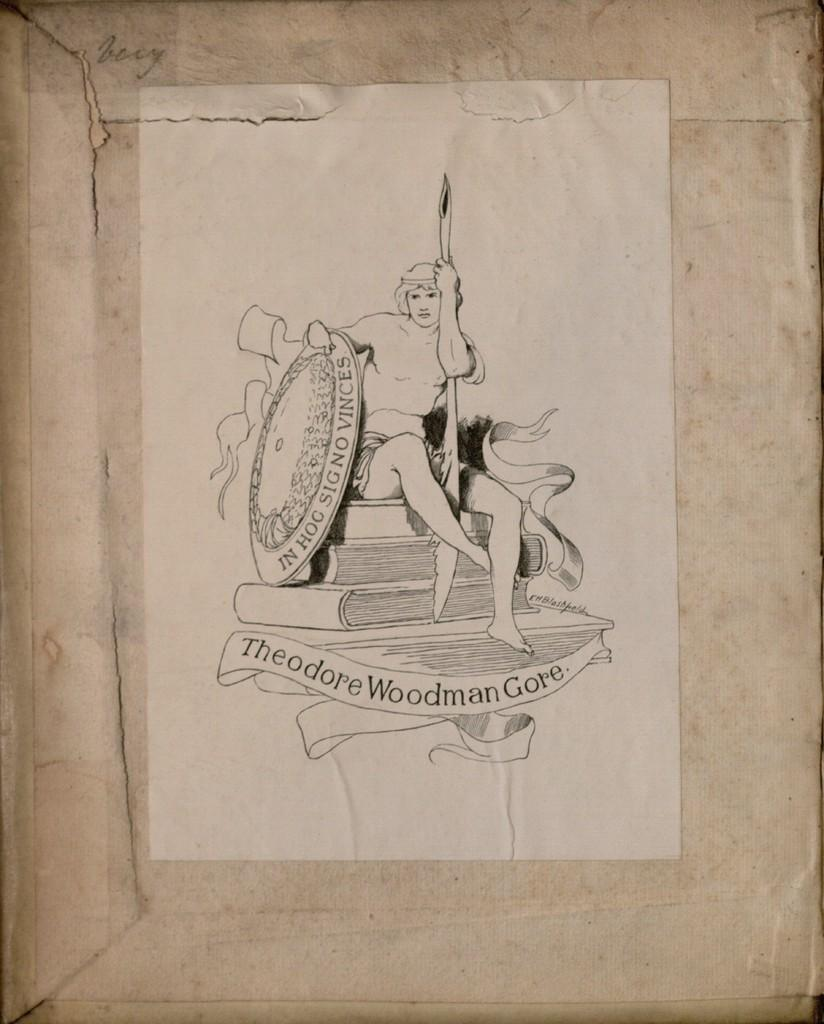What is attached to the wall in the image? There is a paper pasted on the wall in the image. What type of caption can be seen on the maid's uniform in the image? There is no maid or uniform present in the image; it only features a paper pasted on the wall. 